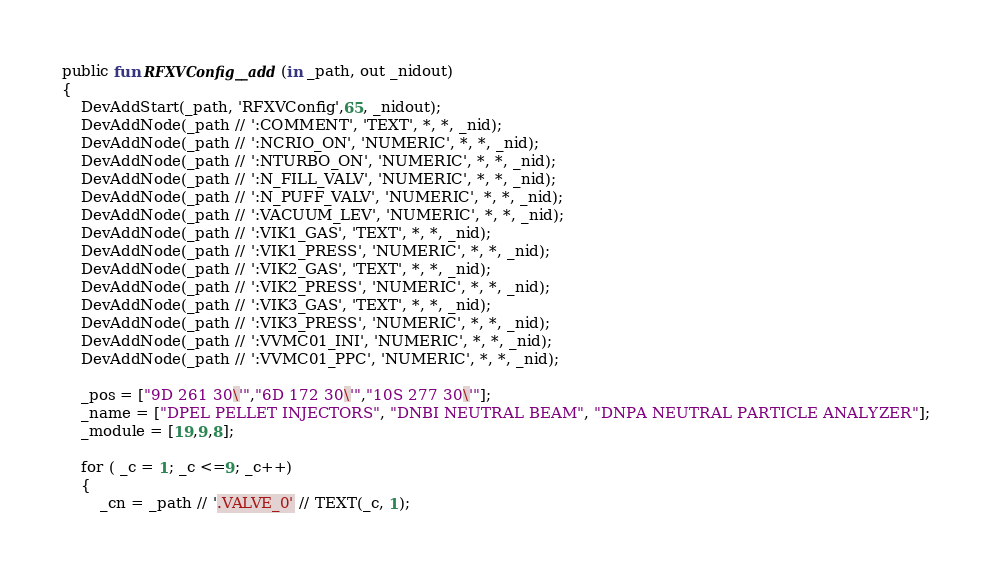<code> <loc_0><loc_0><loc_500><loc_500><_SML_>public fun RFXVConfig__add(in _path, out _nidout)
{
    DevAddStart(_path, 'RFXVConfig',65, _nidout);
    DevAddNode(_path // ':COMMENT', 'TEXT', *, *, _nid);
    DevAddNode(_path // ':NCRIO_ON', 'NUMERIC', *, *, _nid);
    DevAddNode(_path // ':NTURBO_ON', 'NUMERIC', *, *, _nid);
    DevAddNode(_path // ':N_FILL_VALV', 'NUMERIC', *, *, _nid);
    DevAddNode(_path // ':N_PUFF_VALV', 'NUMERIC', *, *, _nid);
    DevAddNode(_path // ':VACUUM_LEV', 'NUMERIC', *, *, _nid);
    DevAddNode(_path // ':VIK1_GAS', 'TEXT', *, *, _nid);
    DevAddNode(_path // ':VIK1_PRESS', 'NUMERIC', *, *, _nid);
    DevAddNode(_path // ':VIK2_GAS', 'TEXT', *, *, _nid);
    DevAddNode(_path // ':VIK2_PRESS', 'NUMERIC', *, *, _nid);
    DevAddNode(_path // ':VIK3_GAS', 'TEXT', *, *, _nid);
    DevAddNode(_path // ':VIK3_PRESS', 'NUMERIC', *, *, _nid);
    DevAddNode(_path // ':VVMC01_INI', 'NUMERIC', *, *, _nid);
    DevAddNode(_path // ':VVMC01_PPC', 'NUMERIC', *, *, _nid);

    _pos = ["9D 261 30\'","6D 172 30\'","10S 277 30\'"];
    _name = ["DPEL PELLET INJECTORS", "DNBI NEUTRAL BEAM", "DNPA NEUTRAL PARTICLE ANALYZER"];
    _module = [19,9,8];

    for ( _c = 1; _c <=9; _c++)
    {
        _cn = _path // '.VALVE_0' // TEXT(_c, 1);</code> 